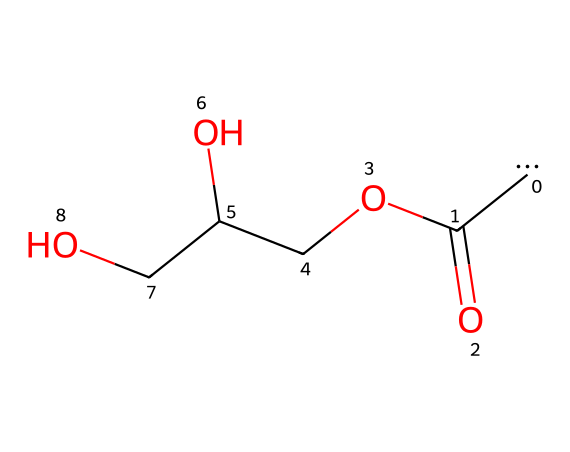What is the molecular formula of this compound? The chemical structure can be interpreted with the SMILES representation. It contains two carbons, one carbonyl group (C=O), and functional groups such as carboxyl (COOH) and ether (OCC). By counting the total atoms from the structure, the molecular formula is derived as C6H12O4.
Answer: C6H12O4 How many carbon atoms are present in the structure? From the SMILES representation, we can easily identify the number of carbon atoms drawn explicitly. There are three carbon atoms in the main chain, and one additional carbon in the carboxyl group, sum totaling to six carbon atoms.
Answer: 6 What type of functional group is present at the end of the molecule? The end of the molecule shows a carboxylic acid functional group, identifiable by the carbonyl (C=O) and hydroxyl (OH) functional groups that are characteristic of carboxylic acids.
Answer: carboxylic acid Is this compound a carbene? A carbene is defined as a molecule with a divalent carbon atom with only six valence electrons, typically represented by a carbon without a bond or with one double bond. Since the SMILES indicates the presence of all typical bonding and extra atoms, this compound does not meet that definition, as it contains a fully bonded structure without a free carbene.
Answer: no What type of reaction would this compound be involved in when breaking down marine algae? This compound, based on its structure containing carboxylic acids and hydroxyl groups, is likely to participate in esterification or hydrolysis reactions during the breakdown of marine algae, which involve the breakdown of complex organic substances into simpler compounds.
Answer: esterification How would this compound react to release a carbene during decomposition? The compound could release a carbene during thermal decomposition or photolytic reactions, where it undergoes elimination or rearrangement, leading to the expulsion of the water molecule and subsequent generation of a carbene intermediate. This would require specific conditions favoring such transformations.
Answer: thermal decomposition 